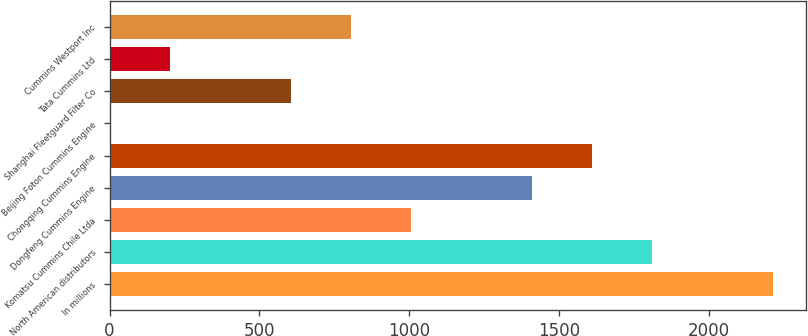Convert chart to OTSL. <chart><loc_0><loc_0><loc_500><loc_500><bar_chart><fcel>In millions<fcel>North American distributors<fcel>Komatsu Cummins Chile Ltda<fcel>Dongfeng Cummins Engine<fcel>Chongqing Cummins Engine<fcel>Beijing Foton Cummins Engine<fcel>Shanghai Fleetguard Filter Co<fcel>Tata Cummins Ltd<fcel>Cummins Westport Inc<nl><fcel>2213.1<fcel>1810.9<fcel>1006.5<fcel>1408.7<fcel>1609.8<fcel>1<fcel>604.3<fcel>202.1<fcel>805.4<nl></chart> 